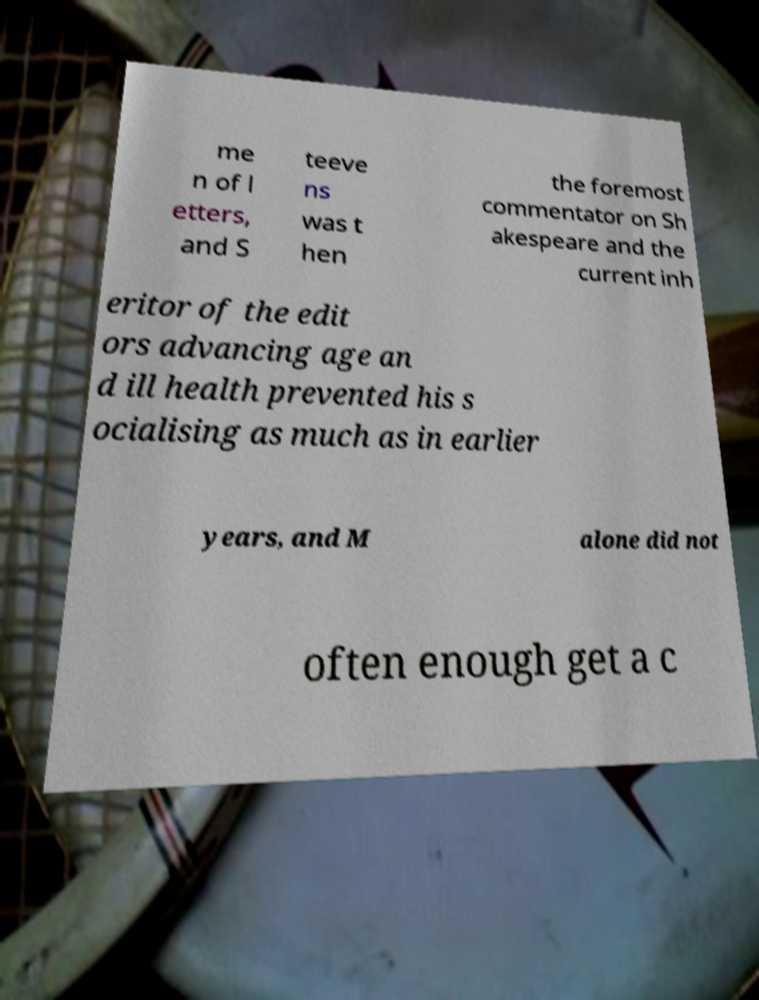Please identify and transcribe the text found in this image. me n of l etters, and S teeve ns was t hen the foremost commentator on Sh akespeare and the current inh eritor of the edit ors advancing age an d ill health prevented his s ocialising as much as in earlier years, and M alone did not often enough get a c 